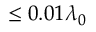Convert formula to latex. <formula><loc_0><loc_0><loc_500><loc_500>\leq 0 . 0 1 \lambda _ { 0 }</formula> 